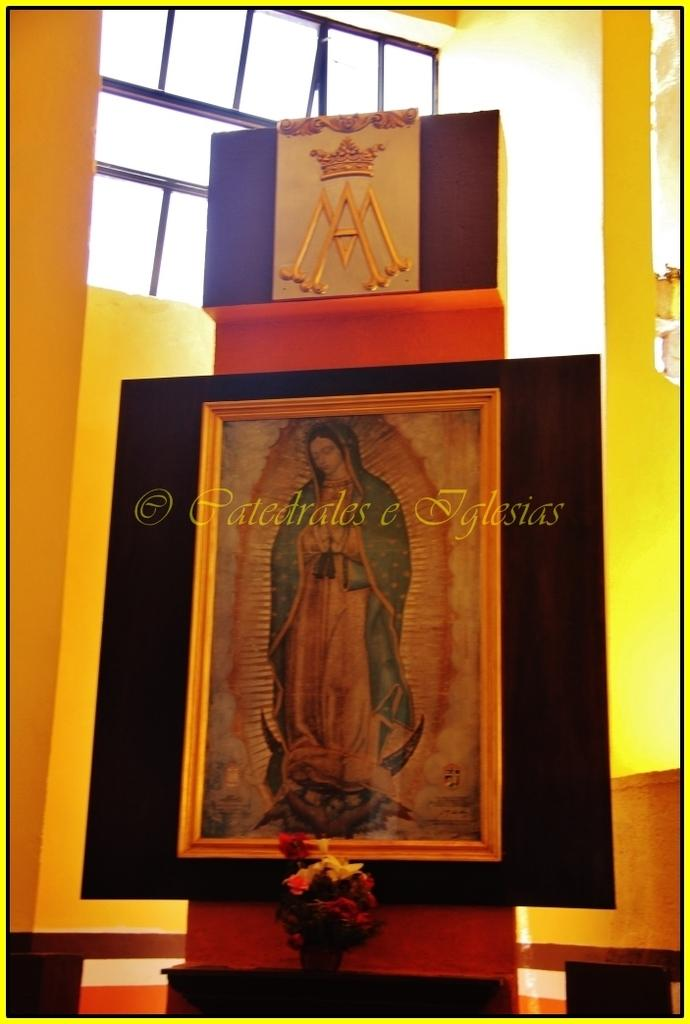Provide a one-sentence caption for the provided image. Framed picture of a woman and the name "Patedrales e Iglesias" on top of it. 